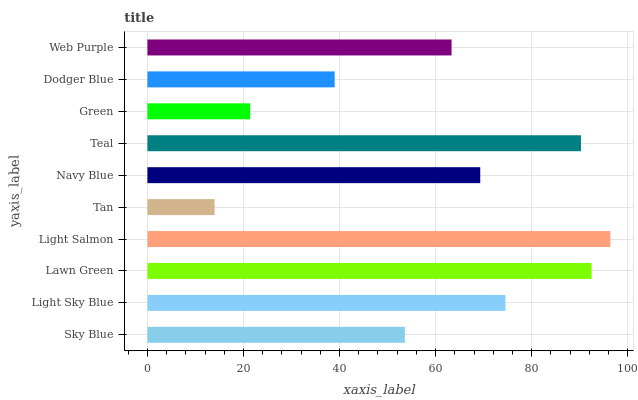Is Tan the minimum?
Answer yes or no. Yes. Is Light Salmon the maximum?
Answer yes or no. Yes. Is Light Sky Blue the minimum?
Answer yes or no. No. Is Light Sky Blue the maximum?
Answer yes or no. No. Is Light Sky Blue greater than Sky Blue?
Answer yes or no. Yes. Is Sky Blue less than Light Sky Blue?
Answer yes or no. Yes. Is Sky Blue greater than Light Sky Blue?
Answer yes or no. No. Is Light Sky Blue less than Sky Blue?
Answer yes or no. No. Is Navy Blue the high median?
Answer yes or no. Yes. Is Web Purple the low median?
Answer yes or no. Yes. Is Dodger Blue the high median?
Answer yes or no. No. Is Light Sky Blue the low median?
Answer yes or no. No. 